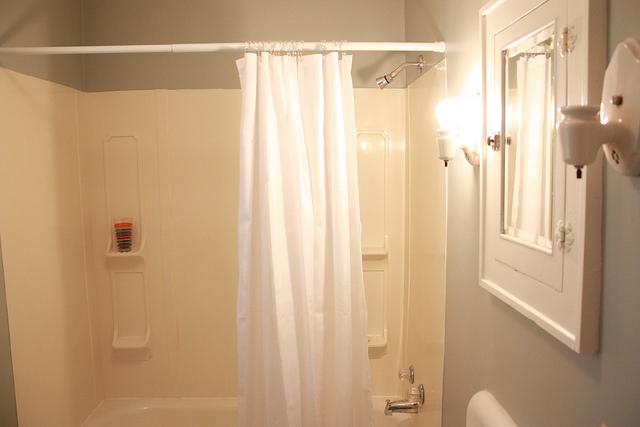What color tile is in the shower?
Answer briefly. White. Do any of the bulbs need replacing?
Write a very short answer. Yes. Why is there a curtain around the tub?
Concise answer only. Yes. Is the shower open or closed?
Be succinct. Open. What color is the curtain on the left?
Write a very short answer. White. Is there a light bulb missing?
Quick response, please. Yes. What is this room?
Keep it brief. Bathroom. 